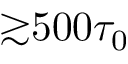Convert formula to latex. <formula><loc_0><loc_0><loc_500><loc_500>{ \gtrsim } 5 0 0 \tau _ { 0 }</formula> 